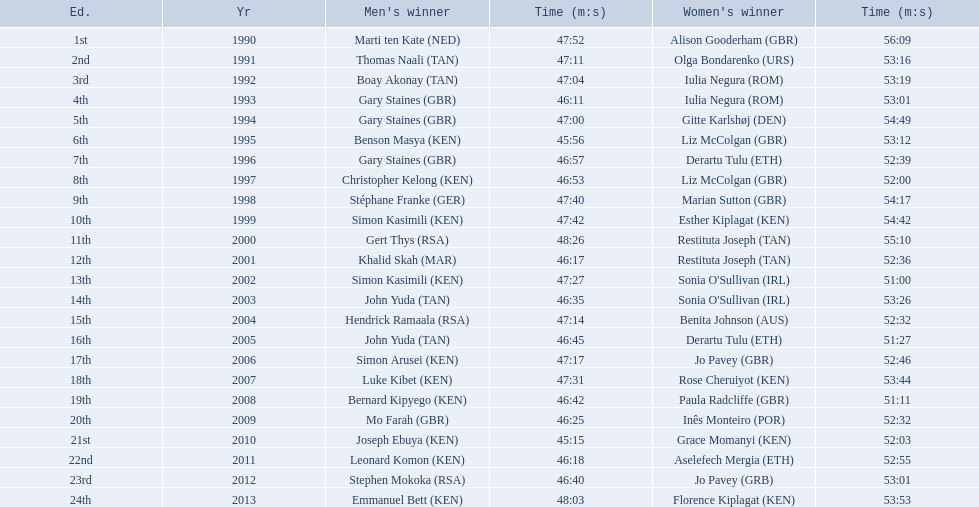What years were the races held? 1990, 1991, 1992, 1993, 1994, 1995, 1996, 1997, 1998, 1999, 2000, 2001, 2002, 2003, 2004, 2005, 2006, 2007, 2008, 2009, 2010, 2011, 2012, 2013. Who was the woman's winner of the 2003 race? Sonia O'Sullivan (IRL). What was her time? 53:26. 